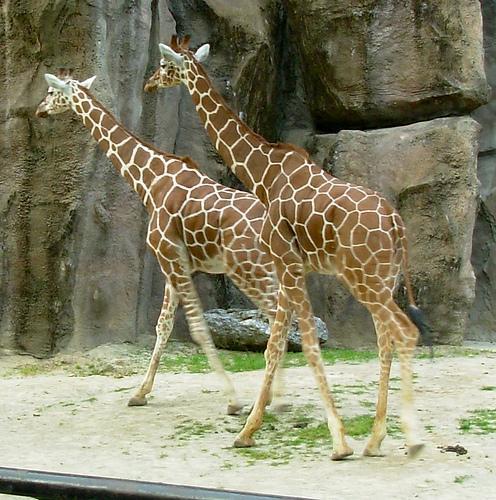How many giraffes are there?
Give a very brief answer. 2. How many Giraffes are in the picture?
Give a very brief answer. 2. How many horns can you see?
Give a very brief answer. 4. How many giraffes are in the picture?
Give a very brief answer. 2. 